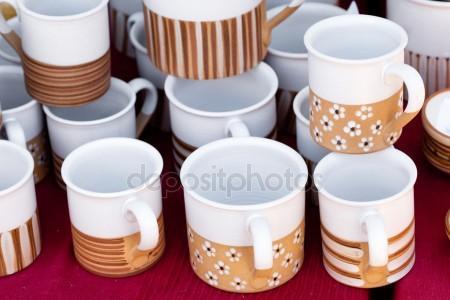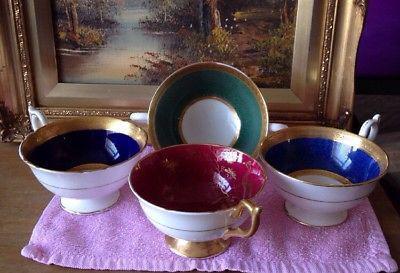The first image is the image on the left, the second image is the image on the right. For the images shown, is this caption "In at least one image there is a total of four cups." true? Answer yes or no. Yes. The first image is the image on the left, the second image is the image on the right. For the images displayed, is the sentence "There are fewer than ten cups in total." factually correct? Answer yes or no. No. 